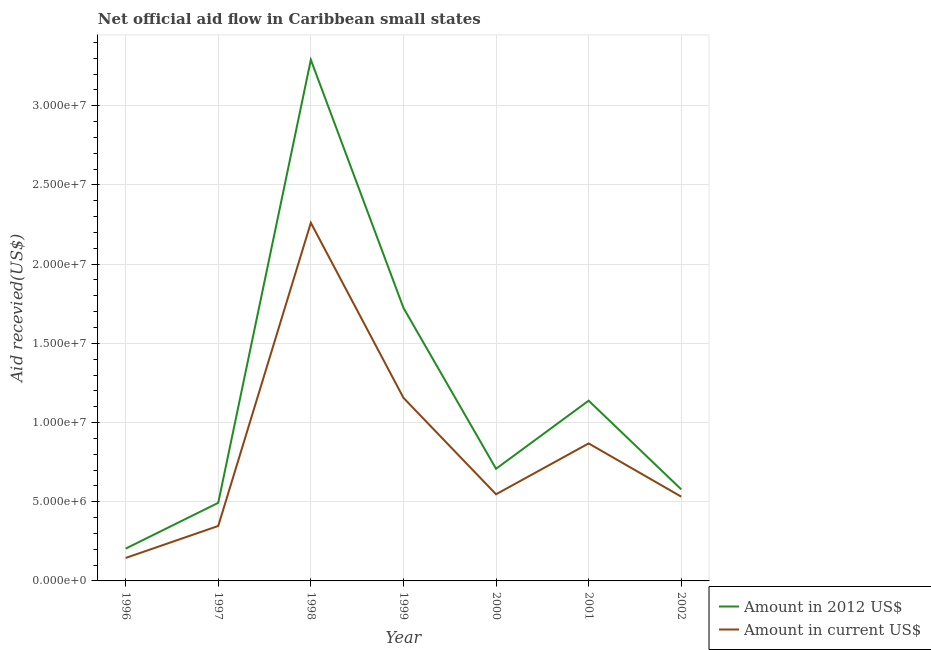How many different coloured lines are there?
Give a very brief answer. 2. Does the line corresponding to amount of aid received(expressed in us$) intersect with the line corresponding to amount of aid received(expressed in 2012 us$)?
Your response must be concise. No. Is the number of lines equal to the number of legend labels?
Your answer should be very brief. Yes. What is the amount of aid received(expressed in 2012 us$) in 2000?
Provide a succinct answer. 7.08e+06. Across all years, what is the maximum amount of aid received(expressed in us$)?
Keep it short and to the point. 2.26e+07. Across all years, what is the minimum amount of aid received(expressed in us$)?
Offer a terse response. 1.45e+06. In which year was the amount of aid received(expressed in us$) maximum?
Keep it short and to the point. 1998. What is the total amount of aid received(expressed in us$) in the graph?
Offer a terse response. 5.86e+07. What is the difference between the amount of aid received(expressed in 2012 us$) in 1996 and that in 2002?
Provide a short and direct response. -3.74e+06. What is the difference between the amount of aid received(expressed in 2012 us$) in 1997 and the amount of aid received(expressed in us$) in 1998?
Keep it short and to the point. -1.77e+07. What is the average amount of aid received(expressed in us$) per year?
Your answer should be very brief. 8.37e+06. In the year 1998, what is the difference between the amount of aid received(expressed in 2012 us$) and amount of aid received(expressed in us$)?
Keep it short and to the point. 1.03e+07. In how many years, is the amount of aid received(expressed in 2012 us$) greater than 4000000 US$?
Your answer should be compact. 6. What is the ratio of the amount of aid received(expressed in 2012 us$) in 1999 to that in 2000?
Your answer should be compact. 2.44. Is the difference between the amount of aid received(expressed in 2012 us$) in 1996 and 2001 greater than the difference between the amount of aid received(expressed in us$) in 1996 and 2001?
Make the answer very short. No. What is the difference between the highest and the second highest amount of aid received(expressed in 2012 us$)?
Ensure brevity in your answer.  1.57e+07. What is the difference between the highest and the lowest amount of aid received(expressed in 2012 us$)?
Your answer should be very brief. 3.09e+07. In how many years, is the amount of aid received(expressed in 2012 us$) greater than the average amount of aid received(expressed in 2012 us$) taken over all years?
Your answer should be compact. 2. Is the sum of the amount of aid received(expressed in us$) in 1997 and 1999 greater than the maximum amount of aid received(expressed in 2012 us$) across all years?
Make the answer very short. No. How many lines are there?
Make the answer very short. 2. Are the values on the major ticks of Y-axis written in scientific E-notation?
Make the answer very short. Yes. Where does the legend appear in the graph?
Keep it short and to the point. Bottom right. How are the legend labels stacked?
Provide a succinct answer. Vertical. What is the title of the graph?
Provide a short and direct response. Net official aid flow in Caribbean small states. What is the label or title of the X-axis?
Your response must be concise. Year. What is the label or title of the Y-axis?
Make the answer very short. Aid recevied(US$). What is the Aid recevied(US$) of Amount in 2012 US$ in 1996?
Your answer should be very brief. 2.04e+06. What is the Aid recevied(US$) of Amount in current US$ in 1996?
Offer a terse response. 1.45e+06. What is the Aid recevied(US$) of Amount in 2012 US$ in 1997?
Offer a terse response. 4.93e+06. What is the Aid recevied(US$) of Amount in current US$ in 1997?
Provide a short and direct response. 3.47e+06. What is the Aid recevied(US$) of Amount in 2012 US$ in 1998?
Your answer should be compact. 3.29e+07. What is the Aid recevied(US$) of Amount in current US$ in 1998?
Your answer should be very brief. 2.26e+07. What is the Aid recevied(US$) of Amount in 2012 US$ in 1999?
Offer a terse response. 1.72e+07. What is the Aid recevied(US$) in Amount in current US$ in 1999?
Your answer should be compact. 1.16e+07. What is the Aid recevied(US$) in Amount in 2012 US$ in 2000?
Provide a short and direct response. 7.08e+06. What is the Aid recevied(US$) in Amount in current US$ in 2000?
Provide a succinct answer. 5.47e+06. What is the Aid recevied(US$) in Amount in 2012 US$ in 2001?
Offer a terse response. 1.14e+07. What is the Aid recevied(US$) in Amount in current US$ in 2001?
Offer a terse response. 8.68e+06. What is the Aid recevied(US$) of Amount in 2012 US$ in 2002?
Your response must be concise. 5.78e+06. What is the Aid recevied(US$) in Amount in current US$ in 2002?
Your response must be concise. 5.32e+06. Across all years, what is the maximum Aid recevied(US$) of Amount in 2012 US$?
Provide a short and direct response. 3.29e+07. Across all years, what is the maximum Aid recevied(US$) in Amount in current US$?
Offer a very short reply. 2.26e+07. Across all years, what is the minimum Aid recevied(US$) in Amount in 2012 US$?
Keep it short and to the point. 2.04e+06. Across all years, what is the minimum Aid recevied(US$) of Amount in current US$?
Keep it short and to the point. 1.45e+06. What is the total Aid recevied(US$) in Amount in 2012 US$ in the graph?
Provide a succinct answer. 8.14e+07. What is the total Aid recevied(US$) of Amount in current US$ in the graph?
Your response must be concise. 5.86e+07. What is the difference between the Aid recevied(US$) in Amount in 2012 US$ in 1996 and that in 1997?
Provide a succinct answer. -2.89e+06. What is the difference between the Aid recevied(US$) in Amount in current US$ in 1996 and that in 1997?
Your answer should be very brief. -2.02e+06. What is the difference between the Aid recevied(US$) of Amount in 2012 US$ in 1996 and that in 1998?
Your answer should be very brief. -3.09e+07. What is the difference between the Aid recevied(US$) in Amount in current US$ in 1996 and that in 1998?
Your response must be concise. -2.12e+07. What is the difference between the Aid recevied(US$) in Amount in 2012 US$ in 1996 and that in 1999?
Keep it short and to the point. -1.52e+07. What is the difference between the Aid recevied(US$) in Amount in current US$ in 1996 and that in 1999?
Your response must be concise. -1.01e+07. What is the difference between the Aid recevied(US$) in Amount in 2012 US$ in 1996 and that in 2000?
Your response must be concise. -5.04e+06. What is the difference between the Aid recevied(US$) in Amount in current US$ in 1996 and that in 2000?
Provide a short and direct response. -4.02e+06. What is the difference between the Aid recevied(US$) in Amount in 2012 US$ in 1996 and that in 2001?
Ensure brevity in your answer.  -9.34e+06. What is the difference between the Aid recevied(US$) in Amount in current US$ in 1996 and that in 2001?
Ensure brevity in your answer.  -7.23e+06. What is the difference between the Aid recevied(US$) of Amount in 2012 US$ in 1996 and that in 2002?
Offer a very short reply. -3.74e+06. What is the difference between the Aid recevied(US$) of Amount in current US$ in 1996 and that in 2002?
Offer a terse response. -3.87e+06. What is the difference between the Aid recevied(US$) in Amount in 2012 US$ in 1997 and that in 1998?
Offer a very short reply. -2.80e+07. What is the difference between the Aid recevied(US$) of Amount in current US$ in 1997 and that in 1998?
Your answer should be compact. -1.91e+07. What is the difference between the Aid recevied(US$) of Amount in 2012 US$ in 1997 and that in 1999?
Your answer should be very brief. -1.23e+07. What is the difference between the Aid recevied(US$) of Amount in current US$ in 1997 and that in 1999?
Your answer should be compact. -8.09e+06. What is the difference between the Aid recevied(US$) of Amount in 2012 US$ in 1997 and that in 2000?
Offer a terse response. -2.15e+06. What is the difference between the Aid recevied(US$) in Amount in current US$ in 1997 and that in 2000?
Ensure brevity in your answer.  -2.00e+06. What is the difference between the Aid recevied(US$) of Amount in 2012 US$ in 1997 and that in 2001?
Offer a terse response. -6.45e+06. What is the difference between the Aid recevied(US$) in Amount in current US$ in 1997 and that in 2001?
Ensure brevity in your answer.  -5.21e+06. What is the difference between the Aid recevied(US$) in Amount in 2012 US$ in 1997 and that in 2002?
Your answer should be compact. -8.50e+05. What is the difference between the Aid recevied(US$) of Amount in current US$ in 1997 and that in 2002?
Your response must be concise. -1.85e+06. What is the difference between the Aid recevied(US$) of Amount in 2012 US$ in 1998 and that in 1999?
Provide a succinct answer. 1.57e+07. What is the difference between the Aid recevied(US$) in Amount in current US$ in 1998 and that in 1999?
Offer a terse response. 1.10e+07. What is the difference between the Aid recevied(US$) in Amount in 2012 US$ in 1998 and that in 2000?
Give a very brief answer. 2.58e+07. What is the difference between the Aid recevied(US$) in Amount in current US$ in 1998 and that in 2000?
Ensure brevity in your answer.  1.71e+07. What is the difference between the Aid recevied(US$) in Amount in 2012 US$ in 1998 and that in 2001?
Offer a very short reply. 2.15e+07. What is the difference between the Aid recevied(US$) in Amount in current US$ in 1998 and that in 2001?
Make the answer very short. 1.39e+07. What is the difference between the Aid recevied(US$) in Amount in 2012 US$ in 1998 and that in 2002?
Give a very brief answer. 2.71e+07. What is the difference between the Aid recevied(US$) in Amount in current US$ in 1998 and that in 2002?
Provide a short and direct response. 1.73e+07. What is the difference between the Aid recevied(US$) in Amount in 2012 US$ in 1999 and that in 2000?
Ensure brevity in your answer.  1.02e+07. What is the difference between the Aid recevied(US$) in Amount in current US$ in 1999 and that in 2000?
Offer a very short reply. 6.09e+06. What is the difference between the Aid recevied(US$) of Amount in 2012 US$ in 1999 and that in 2001?
Offer a very short reply. 5.86e+06. What is the difference between the Aid recevied(US$) in Amount in current US$ in 1999 and that in 2001?
Ensure brevity in your answer.  2.88e+06. What is the difference between the Aid recevied(US$) in Amount in 2012 US$ in 1999 and that in 2002?
Give a very brief answer. 1.15e+07. What is the difference between the Aid recevied(US$) of Amount in current US$ in 1999 and that in 2002?
Make the answer very short. 6.24e+06. What is the difference between the Aid recevied(US$) in Amount in 2012 US$ in 2000 and that in 2001?
Give a very brief answer. -4.30e+06. What is the difference between the Aid recevied(US$) of Amount in current US$ in 2000 and that in 2001?
Your answer should be compact. -3.21e+06. What is the difference between the Aid recevied(US$) of Amount in 2012 US$ in 2000 and that in 2002?
Your answer should be very brief. 1.30e+06. What is the difference between the Aid recevied(US$) of Amount in 2012 US$ in 2001 and that in 2002?
Your answer should be very brief. 5.60e+06. What is the difference between the Aid recevied(US$) in Amount in current US$ in 2001 and that in 2002?
Your answer should be very brief. 3.36e+06. What is the difference between the Aid recevied(US$) in Amount in 2012 US$ in 1996 and the Aid recevied(US$) in Amount in current US$ in 1997?
Ensure brevity in your answer.  -1.43e+06. What is the difference between the Aid recevied(US$) of Amount in 2012 US$ in 1996 and the Aid recevied(US$) of Amount in current US$ in 1998?
Your answer should be compact. -2.06e+07. What is the difference between the Aid recevied(US$) of Amount in 2012 US$ in 1996 and the Aid recevied(US$) of Amount in current US$ in 1999?
Your response must be concise. -9.52e+06. What is the difference between the Aid recevied(US$) in Amount in 2012 US$ in 1996 and the Aid recevied(US$) in Amount in current US$ in 2000?
Your response must be concise. -3.43e+06. What is the difference between the Aid recevied(US$) of Amount in 2012 US$ in 1996 and the Aid recevied(US$) of Amount in current US$ in 2001?
Provide a succinct answer. -6.64e+06. What is the difference between the Aid recevied(US$) of Amount in 2012 US$ in 1996 and the Aid recevied(US$) of Amount in current US$ in 2002?
Your answer should be compact. -3.28e+06. What is the difference between the Aid recevied(US$) of Amount in 2012 US$ in 1997 and the Aid recevied(US$) of Amount in current US$ in 1998?
Provide a short and direct response. -1.77e+07. What is the difference between the Aid recevied(US$) of Amount in 2012 US$ in 1997 and the Aid recevied(US$) of Amount in current US$ in 1999?
Your answer should be compact. -6.63e+06. What is the difference between the Aid recevied(US$) of Amount in 2012 US$ in 1997 and the Aid recevied(US$) of Amount in current US$ in 2000?
Provide a succinct answer. -5.40e+05. What is the difference between the Aid recevied(US$) in Amount in 2012 US$ in 1997 and the Aid recevied(US$) in Amount in current US$ in 2001?
Your response must be concise. -3.75e+06. What is the difference between the Aid recevied(US$) in Amount in 2012 US$ in 1997 and the Aid recevied(US$) in Amount in current US$ in 2002?
Offer a very short reply. -3.90e+05. What is the difference between the Aid recevied(US$) in Amount in 2012 US$ in 1998 and the Aid recevied(US$) in Amount in current US$ in 1999?
Provide a succinct answer. 2.13e+07. What is the difference between the Aid recevied(US$) of Amount in 2012 US$ in 1998 and the Aid recevied(US$) of Amount in current US$ in 2000?
Your response must be concise. 2.74e+07. What is the difference between the Aid recevied(US$) of Amount in 2012 US$ in 1998 and the Aid recevied(US$) of Amount in current US$ in 2001?
Give a very brief answer. 2.42e+07. What is the difference between the Aid recevied(US$) of Amount in 2012 US$ in 1998 and the Aid recevied(US$) of Amount in current US$ in 2002?
Your answer should be compact. 2.76e+07. What is the difference between the Aid recevied(US$) of Amount in 2012 US$ in 1999 and the Aid recevied(US$) of Amount in current US$ in 2000?
Offer a very short reply. 1.18e+07. What is the difference between the Aid recevied(US$) of Amount in 2012 US$ in 1999 and the Aid recevied(US$) of Amount in current US$ in 2001?
Provide a short and direct response. 8.56e+06. What is the difference between the Aid recevied(US$) of Amount in 2012 US$ in 1999 and the Aid recevied(US$) of Amount in current US$ in 2002?
Your response must be concise. 1.19e+07. What is the difference between the Aid recevied(US$) in Amount in 2012 US$ in 2000 and the Aid recevied(US$) in Amount in current US$ in 2001?
Provide a succinct answer. -1.60e+06. What is the difference between the Aid recevied(US$) of Amount in 2012 US$ in 2000 and the Aid recevied(US$) of Amount in current US$ in 2002?
Keep it short and to the point. 1.76e+06. What is the difference between the Aid recevied(US$) of Amount in 2012 US$ in 2001 and the Aid recevied(US$) of Amount in current US$ in 2002?
Your answer should be very brief. 6.06e+06. What is the average Aid recevied(US$) of Amount in 2012 US$ per year?
Your response must be concise. 1.16e+07. What is the average Aid recevied(US$) in Amount in current US$ per year?
Your answer should be very brief. 8.37e+06. In the year 1996, what is the difference between the Aid recevied(US$) of Amount in 2012 US$ and Aid recevied(US$) of Amount in current US$?
Your answer should be very brief. 5.90e+05. In the year 1997, what is the difference between the Aid recevied(US$) in Amount in 2012 US$ and Aid recevied(US$) in Amount in current US$?
Make the answer very short. 1.46e+06. In the year 1998, what is the difference between the Aid recevied(US$) in Amount in 2012 US$ and Aid recevied(US$) in Amount in current US$?
Ensure brevity in your answer.  1.03e+07. In the year 1999, what is the difference between the Aid recevied(US$) of Amount in 2012 US$ and Aid recevied(US$) of Amount in current US$?
Your response must be concise. 5.68e+06. In the year 2000, what is the difference between the Aid recevied(US$) in Amount in 2012 US$ and Aid recevied(US$) in Amount in current US$?
Give a very brief answer. 1.61e+06. In the year 2001, what is the difference between the Aid recevied(US$) in Amount in 2012 US$ and Aid recevied(US$) in Amount in current US$?
Offer a terse response. 2.70e+06. In the year 2002, what is the difference between the Aid recevied(US$) in Amount in 2012 US$ and Aid recevied(US$) in Amount in current US$?
Make the answer very short. 4.60e+05. What is the ratio of the Aid recevied(US$) of Amount in 2012 US$ in 1996 to that in 1997?
Offer a very short reply. 0.41. What is the ratio of the Aid recevied(US$) in Amount in current US$ in 1996 to that in 1997?
Make the answer very short. 0.42. What is the ratio of the Aid recevied(US$) in Amount in 2012 US$ in 1996 to that in 1998?
Your response must be concise. 0.06. What is the ratio of the Aid recevied(US$) of Amount in current US$ in 1996 to that in 1998?
Your response must be concise. 0.06. What is the ratio of the Aid recevied(US$) of Amount in 2012 US$ in 1996 to that in 1999?
Keep it short and to the point. 0.12. What is the ratio of the Aid recevied(US$) of Amount in current US$ in 1996 to that in 1999?
Ensure brevity in your answer.  0.13. What is the ratio of the Aid recevied(US$) in Amount in 2012 US$ in 1996 to that in 2000?
Keep it short and to the point. 0.29. What is the ratio of the Aid recevied(US$) of Amount in current US$ in 1996 to that in 2000?
Your answer should be very brief. 0.27. What is the ratio of the Aid recevied(US$) of Amount in 2012 US$ in 1996 to that in 2001?
Ensure brevity in your answer.  0.18. What is the ratio of the Aid recevied(US$) in Amount in current US$ in 1996 to that in 2001?
Your answer should be compact. 0.17. What is the ratio of the Aid recevied(US$) in Amount in 2012 US$ in 1996 to that in 2002?
Offer a terse response. 0.35. What is the ratio of the Aid recevied(US$) of Amount in current US$ in 1996 to that in 2002?
Offer a very short reply. 0.27. What is the ratio of the Aid recevied(US$) of Amount in 2012 US$ in 1997 to that in 1998?
Your answer should be compact. 0.15. What is the ratio of the Aid recevied(US$) in Amount in current US$ in 1997 to that in 1998?
Offer a very short reply. 0.15. What is the ratio of the Aid recevied(US$) in Amount in 2012 US$ in 1997 to that in 1999?
Provide a short and direct response. 0.29. What is the ratio of the Aid recevied(US$) of Amount in current US$ in 1997 to that in 1999?
Give a very brief answer. 0.3. What is the ratio of the Aid recevied(US$) of Amount in 2012 US$ in 1997 to that in 2000?
Give a very brief answer. 0.7. What is the ratio of the Aid recevied(US$) of Amount in current US$ in 1997 to that in 2000?
Your answer should be very brief. 0.63. What is the ratio of the Aid recevied(US$) in Amount in 2012 US$ in 1997 to that in 2001?
Your answer should be very brief. 0.43. What is the ratio of the Aid recevied(US$) of Amount in current US$ in 1997 to that in 2001?
Make the answer very short. 0.4. What is the ratio of the Aid recevied(US$) of Amount in 2012 US$ in 1997 to that in 2002?
Offer a terse response. 0.85. What is the ratio of the Aid recevied(US$) of Amount in current US$ in 1997 to that in 2002?
Provide a succinct answer. 0.65. What is the ratio of the Aid recevied(US$) of Amount in 2012 US$ in 1998 to that in 1999?
Provide a short and direct response. 1.91. What is the ratio of the Aid recevied(US$) in Amount in current US$ in 1998 to that in 1999?
Make the answer very short. 1.96. What is the ratio of the Aid recevied(US$) in Amount in 2012 US$ in 1998 to that in 2000?
Offer a terse response. 4.65. What is the ratio of the Aid recevied(US$) in Amount in current US$ in 1998 to that in 2000?
Offer a terse response. 4.13. What is the ratio of the Aid recevied(US$) in Amount in 2012 US$ in 1998 to that in 2001?
Give a very brief answer. 2.89. What is the ratio of the Aid recevied(US$) in Amount in current US$ in 1998 to that in 2001?
Make the answer very short. 2.6. What is the ratio of the Aid recevied(US$) of Amount in 2012 US$ in 1998 to that in 2002?
Your answer should be very brief. 5.69. What is the ratio of the Aid recevied(US$) in Amount in current US$ in 1998 to that in 2002?
Give a very brief answer. 4.25. What is the ratio of the Aid recevied(US$) of Amount in 2012 US$ in 1999 to that in 2000?
Your answer should be very brief. 2.44. What is the ratio of the Aid recevied(US$) of Amount in current US$ in 1999 to that in 2000?
Offer a terse response. 2.11. What is the ratio of the Aid recevied(US$) in Amount in 2012 US$ in 1999 to that in 2001?
Your answer should be very brief. 1.51. What is the ratio of the Aid recevied(US$) of Amount in current US$ in 1999 to that in 2001?
Your response must be concise. 1.33. What is the ratio of the Aid recevied(US$) in Amount in 2012 US$ in 1999 to that in 2002?
Your answer should be very brief. 2.98. What is the ratio of the Aid recevied(US$) in Amount in current US$ in 1999 to that in 2002?
Your answer should be compact. 2.17. What is the ratio of the Aid recevied(US$) in Amount in 2012 US$ in 2000 to that in 2001?
Offer a terse response. 0.62. What is the ratio of the Aid recevied(US$) of Amount in current US$ in 2000 to that in 2001?
Ensure brevity in your answer.  0.63. What is the ratio of the Aid recevied(US$) of Amount in 2012 US$ in 2000 to that in 2002?
Offer a terse response. 1.22. What is the ratio of the Aid recevied(US$) in Amount in current US$ in 2000 to that in 2002?
Provide a short and direct response. 1.03. What is the ratio of the Aid recevied(US$) in Amount in 2012 US$ in 2001 to that in 2002?
Offer a terse response. 1.97. What is the ratio of the Aid recevied(US$) in Amount in current US$ in 2001 to that in 2002?
Provide a short and direct response. 1.63. What is the difference between the highest and the second highest Aid recevied(US$) in Amount in 2012 US$?
Provide a short and direct response. 1.57e+07. What is the difference between the highest and the second highest Aid recevied(US$) of Amount in current US$?
Give a very brief answer. 1.10e+07. What is the difference between the highest and the lowest Aid recevied(US$) of Amount in 2012 US$?
Your answer should be compact. 3.09e+07. What is the difference between the highest and the lowest Aid recevied(US$) in Amount in current US$?
Provide a short and direct response. 2.12e+07. 